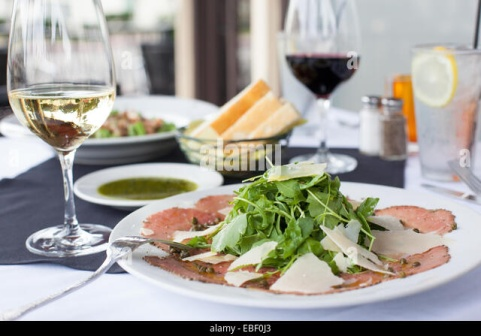Imagine a story occurring in the background of this image. What could be happening? In the background, the soft murmur of conversation fills the air as other diners enjoy their meals under the warm glow of evening lights. A couple celebrates their anniversary at a nearby table, exchanging loving glances and reminiscing about the years they've shared. Meanwhile, a group of friends toasts to a recent success, laughter and clinking glasses punctuating their animated discussion. The restaurant staff moves gracefully among the tables, ensuring every detail is perfect, from refilling wine glasses to presenting beautifully plated dishes with a flourish. The ambiance is one of joy and contentment, with everyone savoring the moment and the exceptional cuisine. 